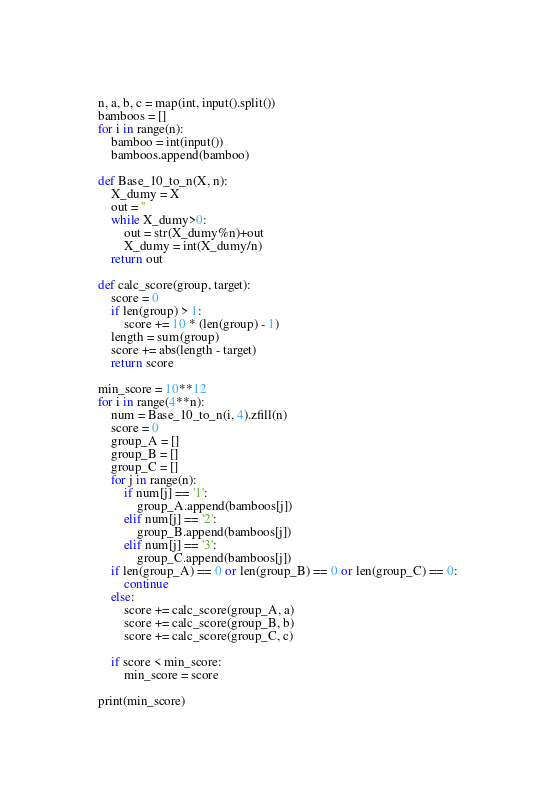<code> <loc_0><loc_0><loc_500><loc_500><_Python_>n, a, b, c = map(int, input().split())
bamboos = []
for i in range(n):
    bamboo = int(input())
    bamboos.append(bamboo)

def Base_10_to_n(X, n):
    X_dumy = X
    out = ''
    while X_dumy>0:
        out = str(X_dumy%n)+out
        X_dumy = int(X_dumy/n)
    return out

def calc_score(group, target):
    score = 0
    if len(group) > 1:
        score += 10 * (len(group) - 1)
    length = sum(group)
    score += abs(length - target)
    return score

min_score = 10**12
for i in range(4**n):
    num = Base_10_to_n(i, 4).zfill(n)
    score = 0
    group_A = []
    group_B = []
    group_C = []
    for j in range(n):
        if num[j] == '1':
            group_A.append(bamboos[j])
        elif num[j] == '2':
            group_B.append(bamboos[j])
        elif num[j] == '3':
            group_C.append(bamboos[j])
    if len(group_A) == 0 or len(group_B) == 0 or len(group_C) == 0:
        continue
    else:
        score += calc_score(group_A, a)
        score += calc_score(group_B, b)
        score += calc_score(group_C, c)

    if score < min_score:
        min_score = score

print(min_score)</code> 